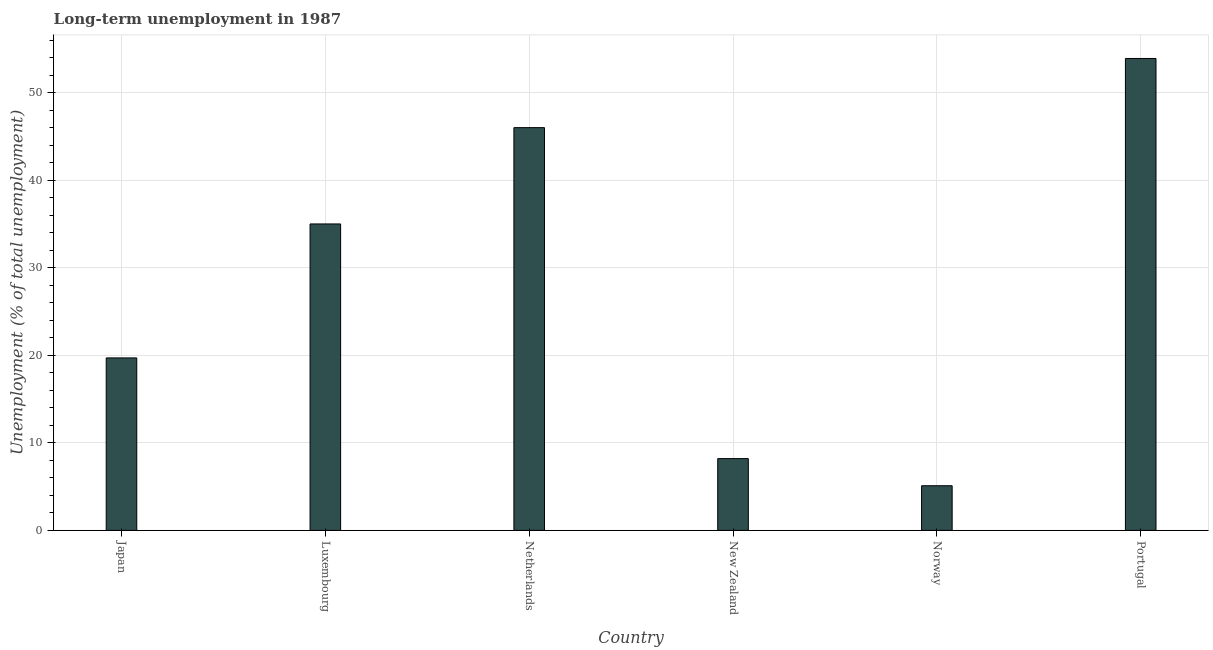Does the graph contain any zero values?
Keep it short and to the point. No. Does the graph contain grids?
Provide a short and direct response. Yes. What is the title of the graph?
Provide a short and direct response. Long-term unemployment in 1987. What is the label or title of the X-axis?
Ensure brevity in your answer.  Country. What is the label or title of the Y-axis?
Offer a very short reply. Unemployment (% of total unemployment). What is the long-term unemployment in New Zealand?
Your response must be concise. 8.2. Across all countries, what is the maximum long-term unemployment?
Your answer should be compact. 53.9. Across all countries, what is the minimum long-term unemployment?
Make the answer very short. 5.1. In which country was the long-term unemployment maximum?
Your response must be concise. Portugal. In which country was the long-term unemployment minimum?
Offer a very short reply. Norway. What is the sum of the long-term unemployment?
Provide a short and direct response. 167.9. What is the difference between the long-term unemployment in Japan and New Zealand?
Give a very brief answer. 11.5. What is the average long-term unemployment per country?
Your response must be concise. 27.98. What is the median long-term unemployment?
Your answer should be very brief. 27.35. In how many countries, is the long-term unemployment greater than 28 %?
Provide a succinct answer. 3. What is the ratio of the long-term unemployment in Netherlands to that in New Zealand?
Offer a very short reply. 5.61. What is the difference between the highest and the lowest long-term unemployment?
Offer a terse response. 48.8. How many bars are there?
Your answer should be very brief. 6. Are all the bars in the graph horizontal?
Ensure brevity in your answer.  No. How many countries are there in the graph?
Make the answer very short. 6. What is the difference between two consecutive major ticks on the Y-axis?
Your response must be concise. 10. Are the values on the major ticks of Y-axis written in scientific E-notation?
Give a very brief answer. No. What is the Unemployment (% of total unemployment) of Japan?
Your answer should be very brief. 19.7. What is the Unemployment (% of total unemployment) of New Zealand?
Ensure brevity in your answer.  8.2. What is the Unemployment (% of total unemployment) of Norway?
Provide a succinct answer. 5.1. What is the Unemployment (% of total unemployment) in Portugal?
Ensure brevity in your answer.  53.9. What is the difference between the Unemployment (% of total unemployment) in Japan and Luxembourg?
Your answer should be compact. -15.3. What is the difference between the Unemployment (% of total unemployment) in Japan and Netherlands?
Ensure brevity in your answer.  -26.3. What is the difference between the Unemployment (% of total unemployment) in Japan and Norway?
Offer a terse response. 14.6. What is the difference between the Unemployment (% of total unemployment) in Japan and Portugal?
Provide a succinct answer. -34.2. What is the difference between the Unemployment (% of total unemployment) in Luxembourg and New Zealand?
Offer a very short reply. 26.8. What is the difference between the Unemployment (% of total unemployment) in Luxembourg and Norway?
Give a very brief answer. 29.9. What is the difference between the Unemployment (% of total unemployment) in Luxembourg and Portugal?
Offer a terse response. -18.9. What is the difference between the Unemployment (% of total unemployment) in Netherlands and New Zealand?
Provide a short and direct response. 37.8. What is the difference between the Unemployment (% of total unemployment) in Netherlands and Norway?
Your answer should be compact. 40.9. What is the difference between the Unemployment (% of total unemployment) in New Zealand and Norway?
Ensure brevity in your answer.  3.1. What is the difference between the Unemployment (% of total unemployment) in New Zealand and Portugal?
Ensure brevity in your answer.  -45.7. What is the difference between the Unemployment (% of total unemployment) in Norway and Portugal?
Offer a terse response. -48.8. What is the ratio of the Unemployment (% of total unemployment) in Japan to that in Luxembourg?
Keep it short and to the point. 0.56. What is the ratio of the Unemployment (% of total unemployment) in Japan to that in Netherlands?
Give a very brief answer. 0.43. What is the ratio of the Unemployment (% of total unemployment) in Japan to that in New Zealand?
Offer a terse response. 2.4. What is the ratio of the Unemployment (% of total unemployment) in Japan to that in Norway?
Your answer should be compact. 3.86. What is the ratio of the Unemployment (% of total unemployment) in Japan to that in Portugal?
Your response must be concise. 0.36. What is the ratio of the Unemployment (% of total unemployment) in Luxembourg to that in Netherlands?
Your answer should be very brief. 0.76. What is the ratio of the Unemployment (% of total unemployment) in Luxembourg to that in New Zealand?
Give a very brief answer. 4.27. What is the ratio of the Unemployment (% of total unemployment) in Luxembourg to that in Norway?
Provide a succinct answer. 6.86. What is the ratio of the Unemployment (% of total unemployment) in Luxembourg to that in Portugal?
Give a very brief answer. 0.65. What is the ratio of the Unemployment (% of total unemployment) in Netherlands to that in New Zealand?
Ensure brevity in your answer.  5.61. What is the ratio of the Unemployment (% of total unemployment) in Netherlands to that in Norway?
Offer a terse response. 9.02. What is the ratio of the Unemployment (% of total unemployment) in Netherlands to that in Portugal?
Offer a terse response. 0.85. What is the ratio of the Unemployment (% of total unemployment) in New Zealand to that in Norway?
Provide a succinct answer. 1.61. What is the ratio of the Unemployment (% of total unemployment) in New Zealand to that in Portugal?
Offer a very short reply. 0.15. What is the ratio of the Unemployment (% of total unemployment) in Norway to that in Portugal?
Your answer should be very brief. 0.1. 